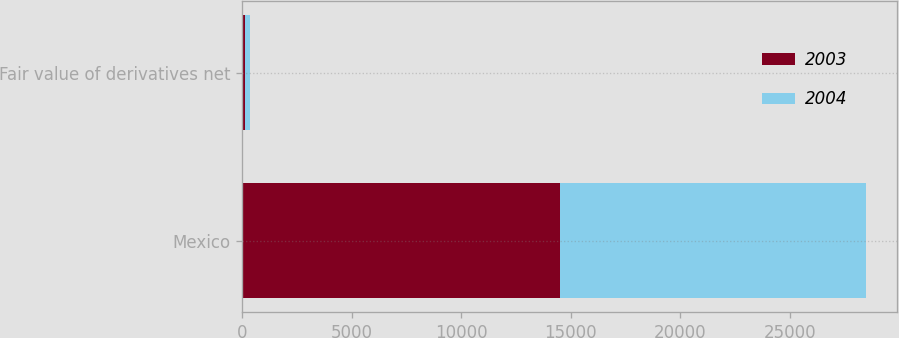Convert chart to OTSL. <chart><loc_0><loc_0><loc_500><loc_500><stacked_bar_chart><ecel><fcel>Mexico<fcel>Fair value of derivatives net<nl><fcel>2003<fcel>14518<fcel>138<nl><fcel>2004<fcel>13962<fcel>198<nl></chart> 